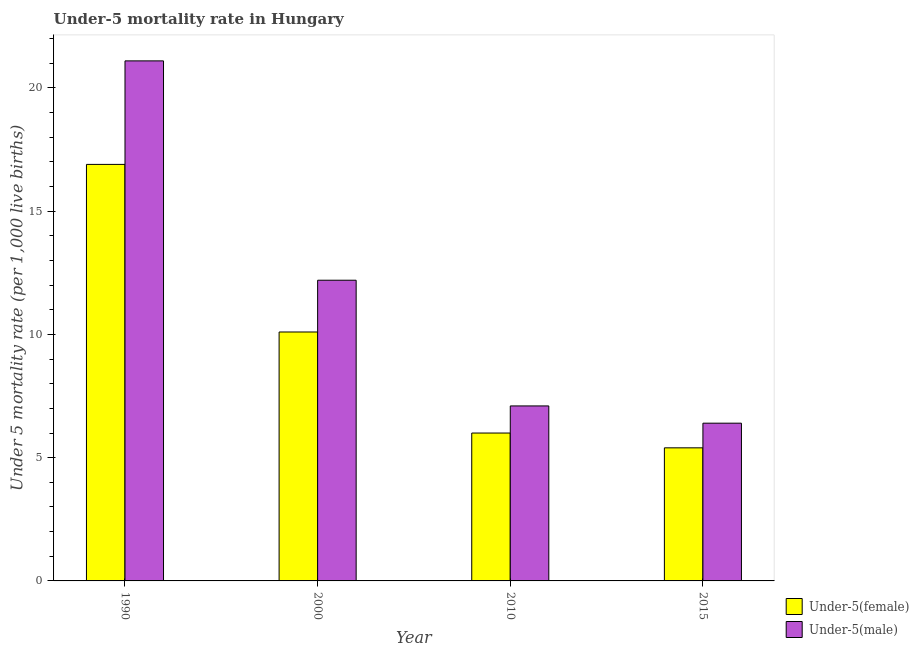How many different coloured bars are there?
Make the answer very short. 2. How many groups of bars are there?
Provide a short and direct response. 4. How many bars are there on the 1st tick from the right?
Provide a short and direct response. 2. In how many cases, is the number of bars for a given year not equal to the number of legend labels?
Offer a terse response. 0. Across all years, what is the maximum under-5 female mortality rate?
Your answer should be compact. 16.9. Across all years, what is the minimum under-5 male mortality rate?
Provide a succinct answer. 6.4. In which year was the under-5 female mortality rate maximum?
Offer a very short reply. 1990. In which year was the under-5 female mortality rate minimum?
Give a very brief answer. 2015. What is the total under-5 female mortality rate in the graph?
Provide a succinct answer. 38.4. What is the difference between the under-5 female mortality rate in 1990 and that in 2015?
Keep it short and to the point. 11.5. What is the difference between the under-5 male mortality rate in 2000 and the under-5 female mortality rate in 2010?
Your answer should be compact. 5.1. What is the average under-5 male mortality rate per year?
Keep it short and to the point. 11.7. In the year 2010, what is the difference between the under-5 female mortality rate and under-5 male mortality rate?
Offer a terse response. 0. In how many years, is the under-5 female mortality rate greater than 10?
Offer a very short reply. 2. What is the ratio of the under-5 female mortality rate in 1990 to that in 2000?
Give a very brief answer. 1.67. What is the difference between the highest and the second highest under-5 male mortality rate?
Ensure brevity in your answer.  8.9. What is the difference between the highest and the lowest under-5 female mortality rate?
Provide a short and direct response. 11.5. In how many years, is the under-5 male mortality rate greater than the average under-5 male mortality rate taken over all years?
Offer a terse response. 2. What does the 1st bar from the left in 2015 represents?
Offer a terse response. Under-5(female). What does the 2nd bar from the right in 2000 represents?
Your answer should be compact. Under-5(female). How many bars are there?
Keep it short and to the point. 8. Are the values on the major ticks of Y-axis written in scientific E-notation?
Provide a succinct answer. No. Does the graph contain any zero values?
Offer a terse response. No. Does the graph contain grids?
Ensure brevity in your answer.  No. How many legend labels are there?
Your response must be concise. 2. How are the legend labels stacked?
Offer a very short reply. Vertical. What is the title of the graph?
Provide a succinct answer. Under-5 mortality rate in Hungary. Does "Chemicals" appear as one of the legend labels in the graph?
Provide a short and direct response. No. What is the label or title of the Y-axis?
Ensure brevity in your answer.  Under 5 mortality rate (per 1,0 live births). What is the Under 5 mortality rate (per 1,000 live births) of Under-5(male) in 1990?
Provide a succinct answer. 21.1. What is the Under 5 mortality rate (per 1,000 live births) of Under-5(female) in 2000?
Provide a short and direct response. 10.1. What is the Under 5 mortality rate (per 1,000 live births) in Under-5(male) in 2000?
Your response must be concise. 12.2. What is the Under 5 mortality rate (per 1,000 live births) of Under-5(female) in 2010?
Make the answer very short. 6. What is the Under 5 mortality rate (per 1,000 live births) in Under-5(male) in 2015?
Your answer should be very brief. 6.4. Across all years, what is the maximum Under 5 mortality rate (per 1,000 live births) in Under-5(male)?
Your answer should be very brief. 21.1. Across all years, what is the minimum Under 5 mortality rate (per 1,000 live births) of Under-5(female)?
Provide a short and direct response. 5.4. Across all years, what is the minimum Under 5 mortality rate (per 1,000 live births) in Under-5(male)?
Your answer should be compact. 6.4. What is the total Under 5 mortality rate (per 1,000 live births) in Under-5(female) in the graph?
Offer a very short reply. 38.4. What is the total Under 5 mortality rate (per 1,000 live births) of Under-5(male) in the graph?
Provide a short and direct response. 46.8. What is the difference between the Under 5 mortality rate (per 1,000 live births) of Under-5(male) in 1990 and that in 2000?
Ensure brevity in your answer.  8.9. What is the difference between the Under 5 mortality rate (per 1,000 live births) of Under-5(female) in 1990 and that in 2010?
Give a very brief answer. 10.9. What is the difference between the Under 5 mortality rate (per 1,000 live births) in Under-5(male) in 1990 and that in 2010?
Your answer should be compact. 14. What is the difference between the Under 5 mortality rate (per 1,000 live births) of Under-5(female) in 1990 and that in 2015?
Your response must be concise. 11.5. What is the difference between the Under 5 mortality rate (per 1,000 live births) of Under-5(male) in 1990 and that in 2015?
Give a very brief answer. 14.7. What is the difference between the Under 5 mortality rate (per 1,000 live births) in Under-5(female) in 2000 and that in 2010?
Offer a very short reply. 4.1. What is the difference between the Under 5 mortality rate (per 1,000 live births) of Under-5(male) in 2000 and that in 2015?
Your answer should be compact. 5.8. What is the difference between the Under 5 mortality rate (per 1,000 live births) of Under-5(male) in 2010 and that in 2015?
Offer a very short reply. 0.7. What is the difference between the Under 5 mortality rate (per 1,000 live births) of Under-5(female) in 1990 and the Under 5 mortality rate (per 1,000 live births) of Under-5(male) in 2010?
Provide a short and direct response. 9.8. What is the difference between the Under 5 mortality rate (per 1,000 live births) of Under-5(female) in 2000 and the Under 5 mortality rate (per 1,000 live births) of Under-5(male) in 2015?
Keep it short and to the point. 3.7. What is the difference between the Under 5 mortality rate (per 1,000 live births) in Under-5(female) in 2010 and the Under 5 mortality rate (per 1,000 live births) in Under-5(male) in 2015?
Your answer should be very brief. -0.4. What is the average Under 5 mortality rate (per 1,000 live births) in Under-5(female) per year?
Provide a short and direct response. 9.6. In the year 1990, what is the difference between the Under 5 mortality rate (per 1,000 live births) of Under-5(female) and Under 5 mortality rate (per 1,000 live births) of Under-5(male)?
Make the answer very short. -4.2. What is the ratio of the Under 5 mortality rate (per 1,000 live births) of Under-5(female) in 1990 to that in 2000?
Your answer should be very brief. 1.67. What is the ratio of the Under 5 mortality rate (per 1,000 live births) of Under-5(male) in 1990 to that in 2000?
Your answer should be compact. 1.73. What is the ratio of the Under 5 mortality rate (per 1,000 live births) in Under-5(female) in 1990 to that in 2010?
Give a very brief answer. 2.82. What is the ratio of the Under 5 mortality rate (per 1,000 live births) of Under-5(male) in 1990 to that in 2010?
Ensure brevity in your answer.  2.97. What is the ratio of the Under 5 mortality rate (per 1,000 live births) in Under-5(female) in 1990 to that in 2015?
Keep it short and to the point. 3.13. What is the ratio of the Under 5 mortality rate (per 1,000 live births) of Under-5(male) in 1990 to that in 2015?
Provide a short and direct response. 3.3. What is the ratio of the Under 5 mortality rate (per 1,000 live births) in Under-5(female) in 2000 to that in 2010?
Keep it short and to the point. 1.68. What is the ratio of the Under 5 mortality rate (per 1,000 live births) in Under-5(male) in 2000 to that in 2010?
Keep it short and to the point. 1.72. What is the ratio of the Under 5 mortality rate (per 1,000 live births) in Under-5(female) in 2000 to that in 2015?
Make the answer very short. 1.87. What is the ratio of the Under 5 mortality rate (per 1,000 live births) of Under-5(male) in 2000 to that in 2015?
Keep it short and to the point. 1.91. What is the ratio of the Under 5 mortality rate (per 1,000 live births) in Under-5(male) in 2010 to that in 2015?
Provide a short and direct response. 1.11. What is the difference between the highest and the second highest Under 5 mortality rate (per 1,000 live births) of Under-5(male)?
Provide a succinct answer. 8.9. 